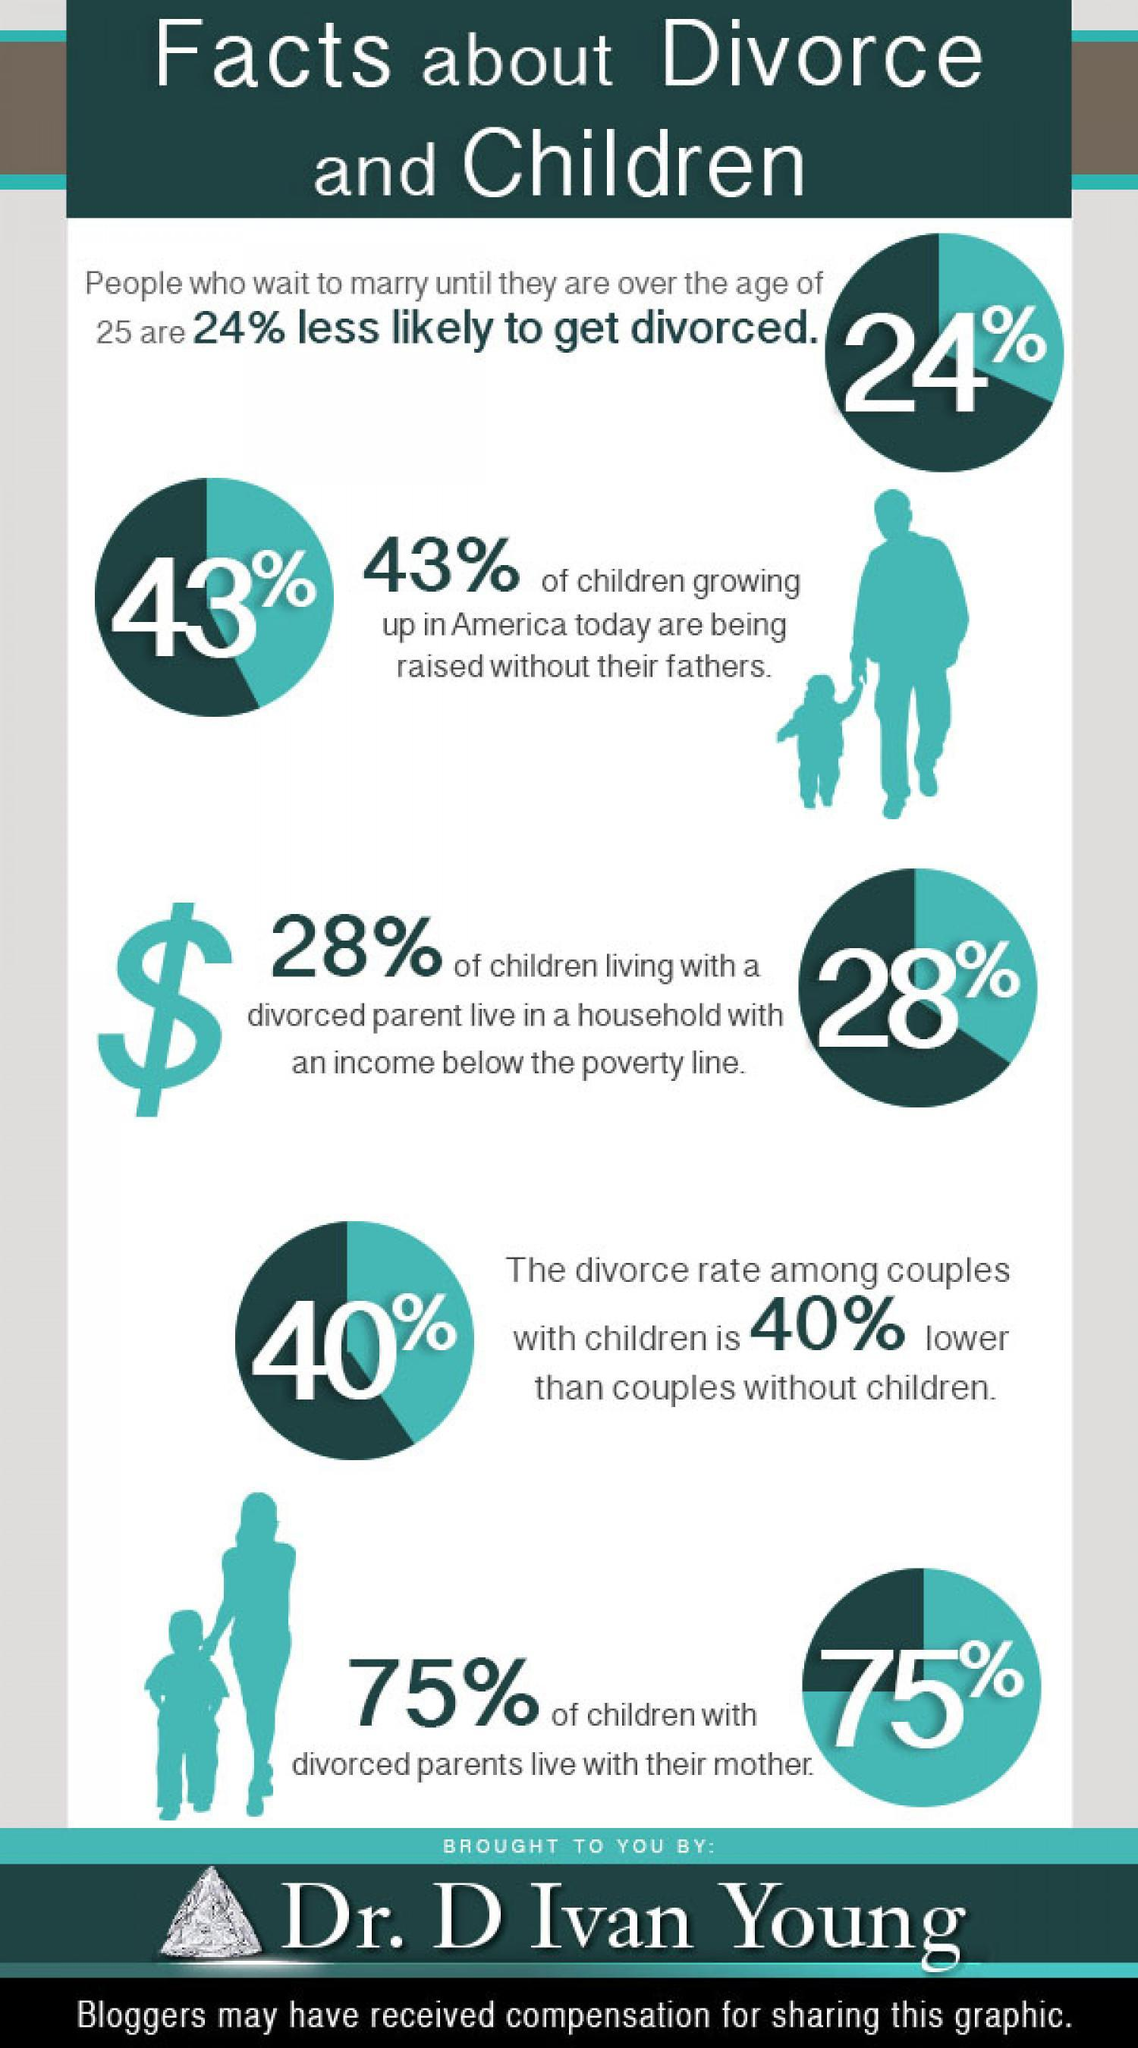What percentage of children living with divorced parents live above the poverty line?
Answer the question with a short phrase. 72% What percentage of children with divorced parents live without their mother? 25% What percentage of children in America are raised with their fathers? 57% 